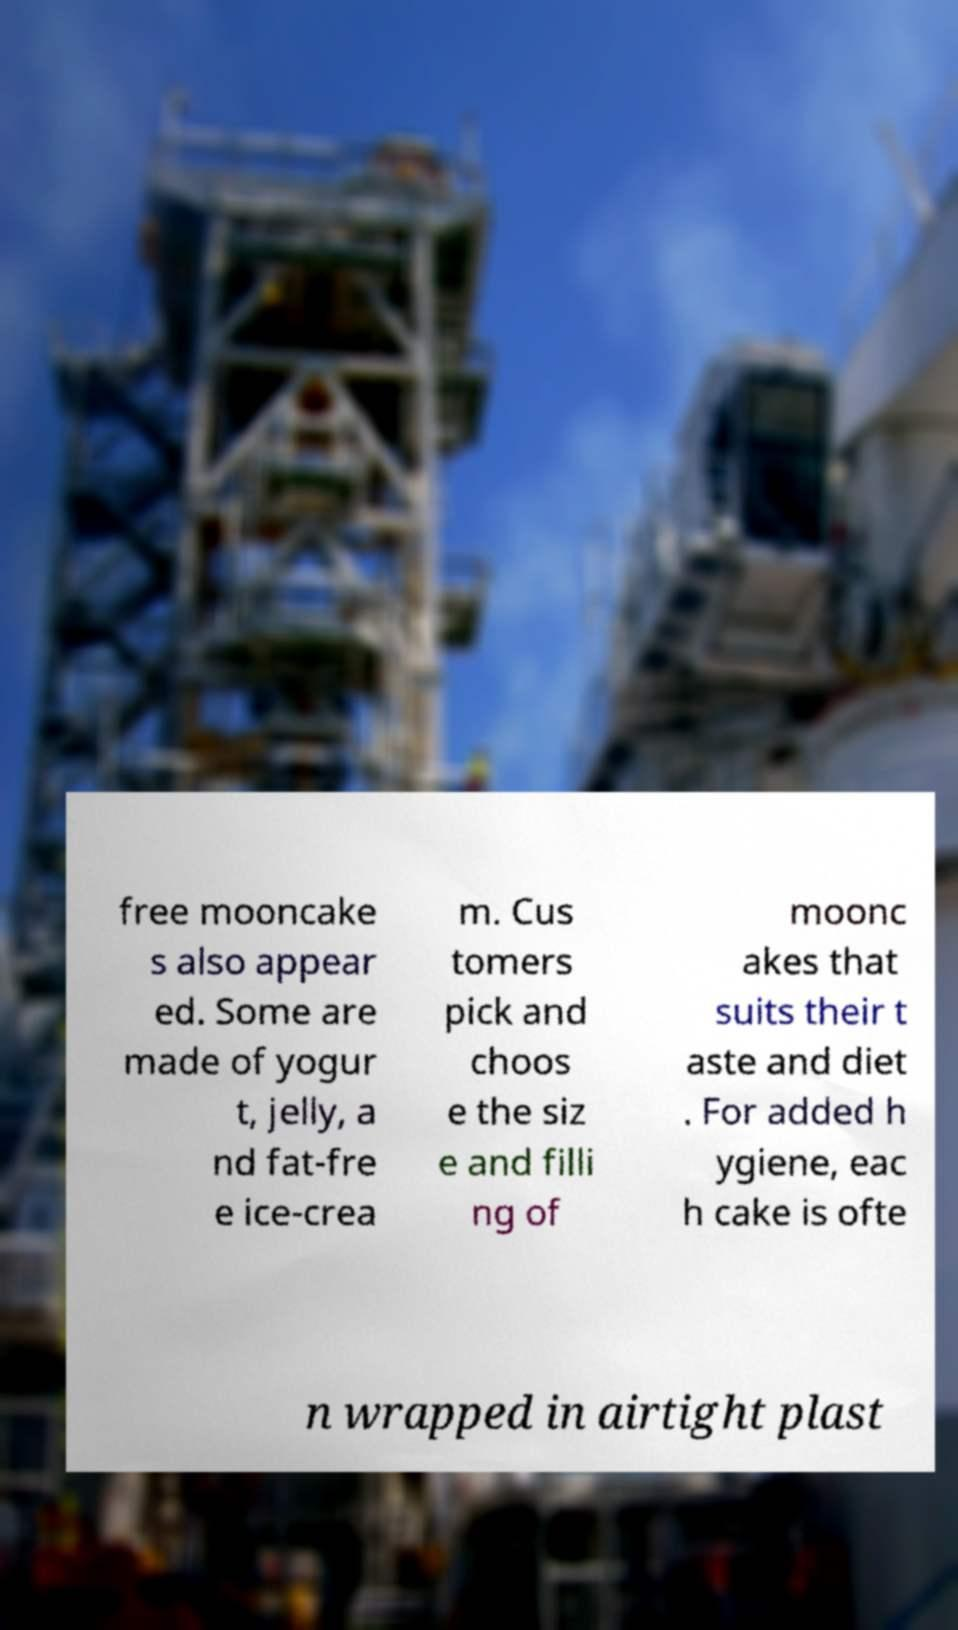There's text embedded in this image that I need extracted. Can you transcribe it verbatim? free mooncake s also appear ed. Some are made of yogur t, jelly, a nd fat-fre e ice-crea m. Cus tomers pick and choos e the siz e and filli ng of moonc akes that suits their t aste and diet . For added h ygiene, eac h cake is ofte n wrapped in airtight plast 